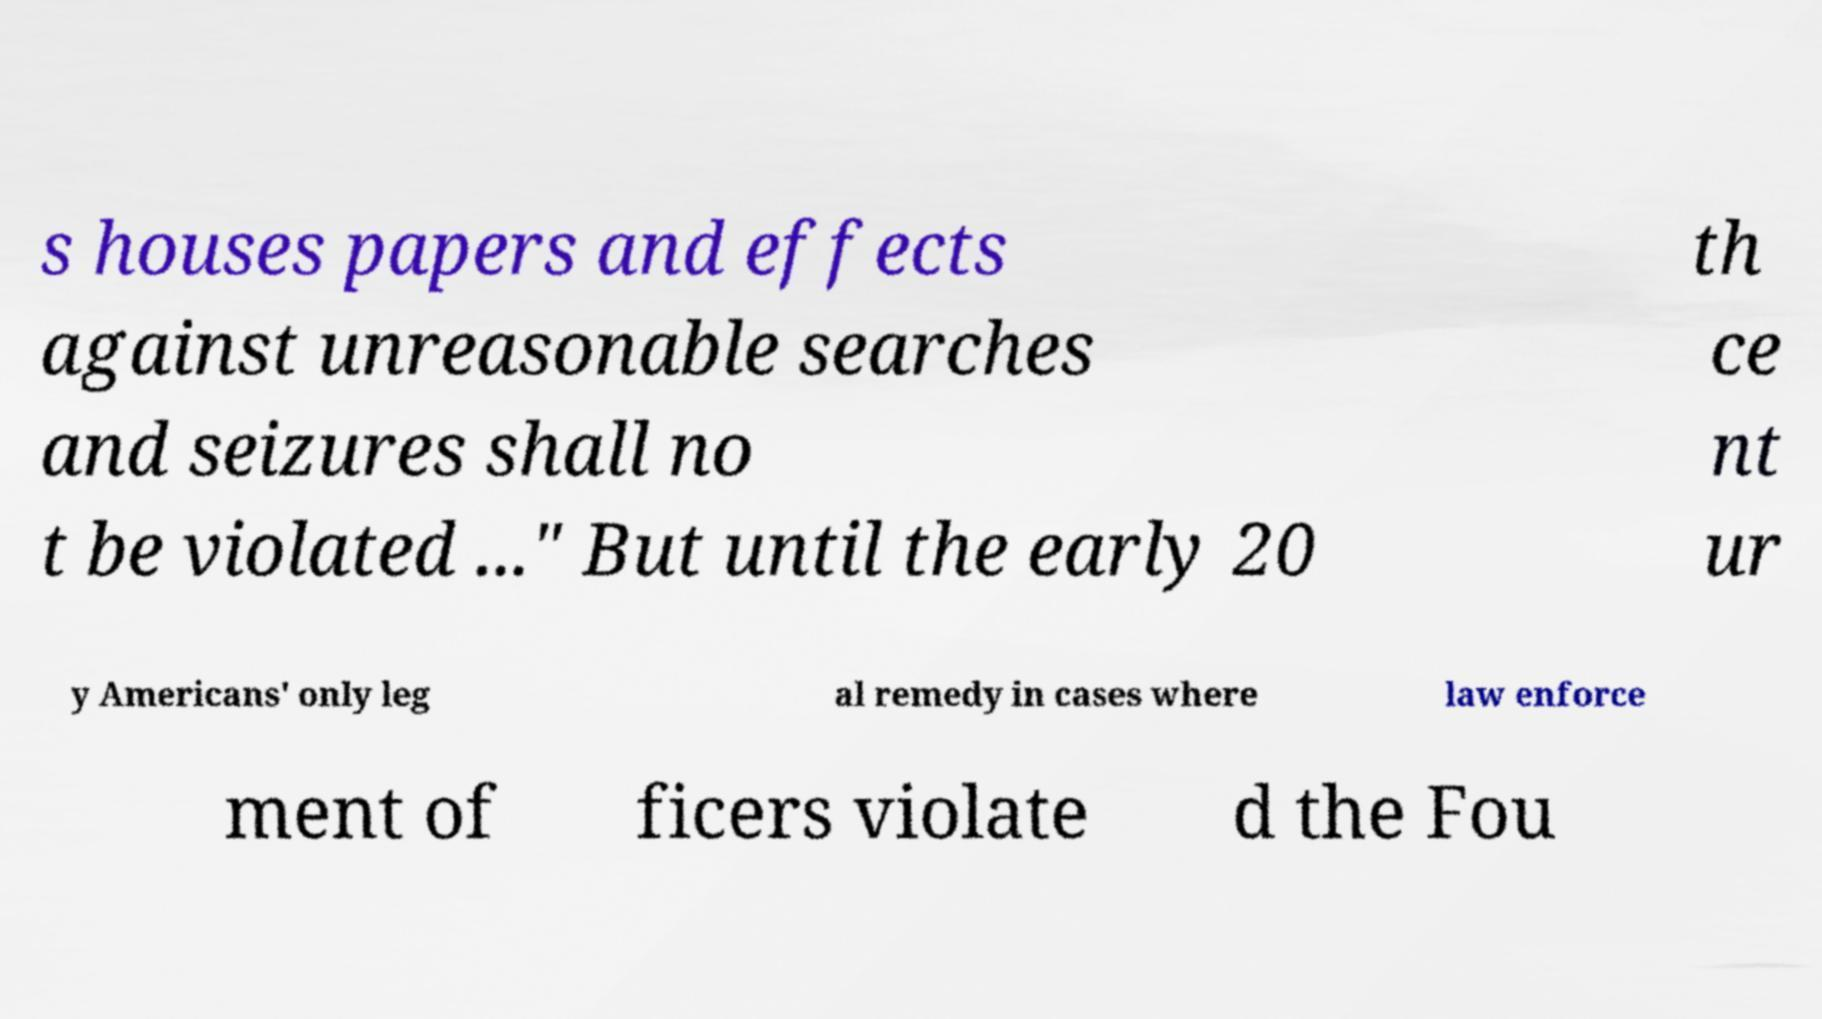I need the written content from this picture converted into text. Can you do that? s houses papers and effects against unreasonable searches and seizures shall no t be violated ..." But until the early 20 th ce nt ur y Americans' only leg al remedy in cases where law enforce ment of ficers violate d the Fou 